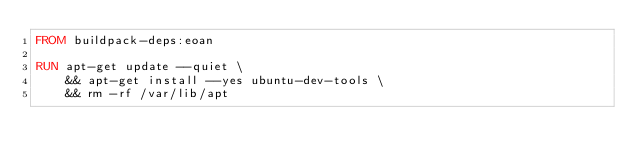<code> <loc_0><loc_0><loc_500><loc_500><_Dockerfile_>FROM buildpack-deps:eoan

RUN apt-get update --quiet \
    && apt-get install --yes ubuntu-dev-tools \
    && rm -rf /var/lib/apt
</code> 